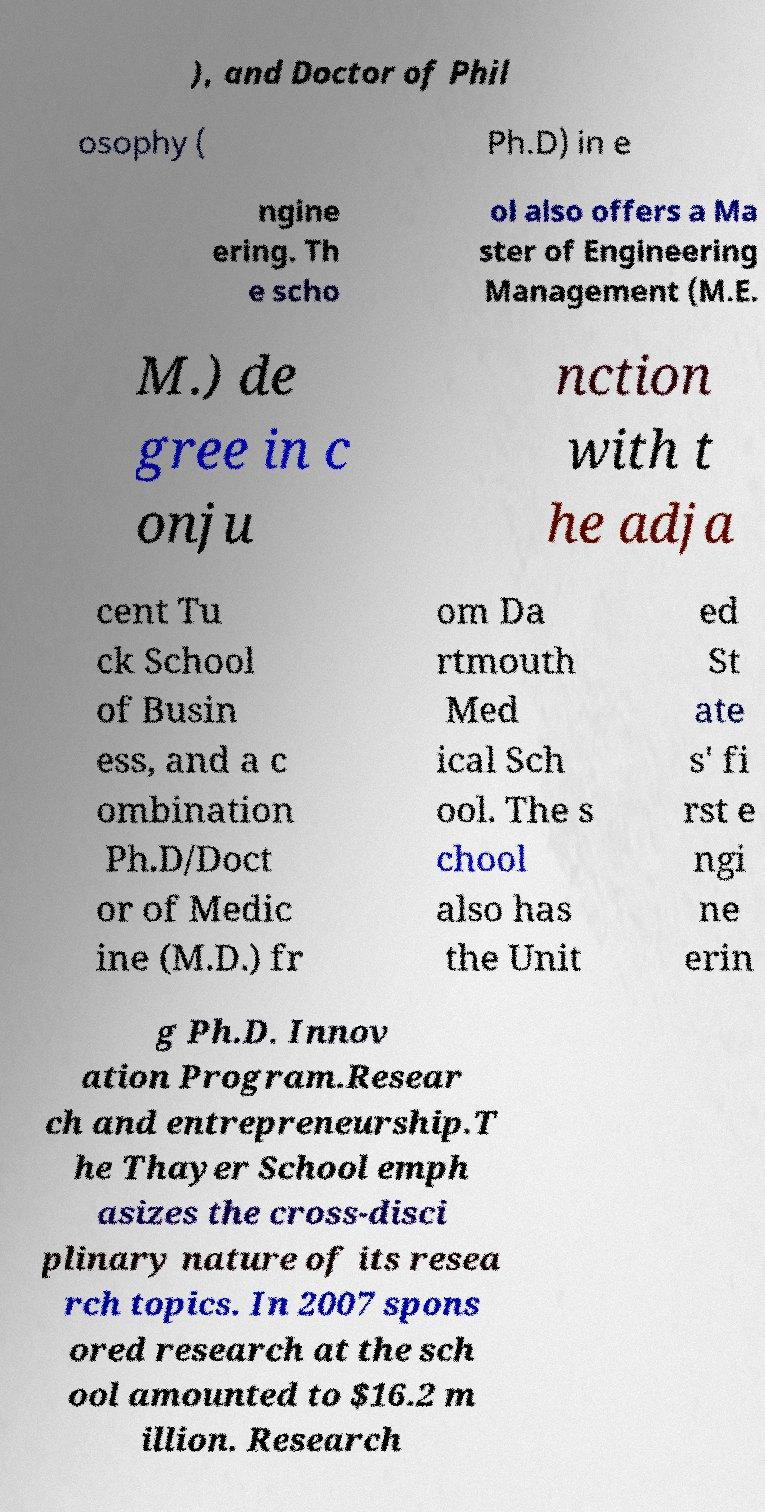Please identify and transcribe the text found in this image. ), and Doctor of Phil osophy ( Ph.D) in e ngine ering. Th e scho ol also offers a Ma ster of Engineering Management (M.E. M.) de gree in c onju nction with t he adja cent Tu ck School of Busin ess, and a c ombination Ph.D/Doct or of Medic ine (M.D.) fr om Da rtmouth Med ical Sch ool. The s chool also has the Unit ed St ate s' fi rst e ngi ne erin g Ph.D. Innov ation Program.Resear ch and entrepreneurship.T he Thayer School emph asizes the cross-disci plinary nature of its resea rch topics. In 2007 spons ored research at the sch ool amounted to $16.2 m illion. Research 